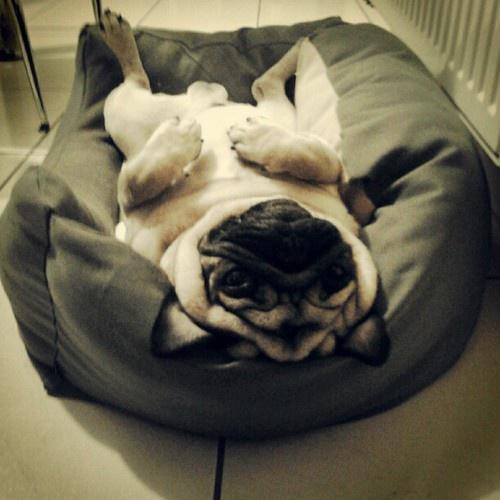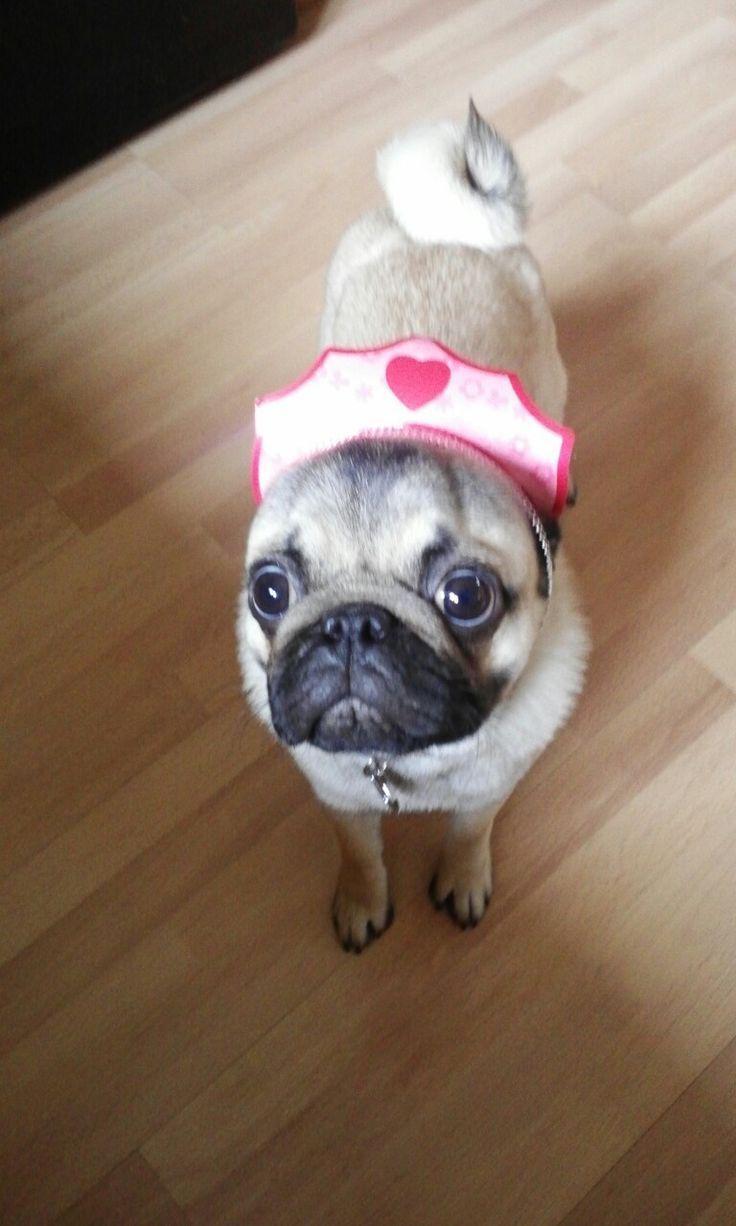The first image is the image on the left, the second image is the image on the right. Examine the images to the left and right. Is the description "An image shows a pug dog wearing some type of band over its head." accurate? Answer yes or no. Yes. The first image is the image on the left, the second image is the image on the right. Examine the images to the left and right. Is the description "Thre are two dogs in total." accurate? Answer yes or no. Yes. 